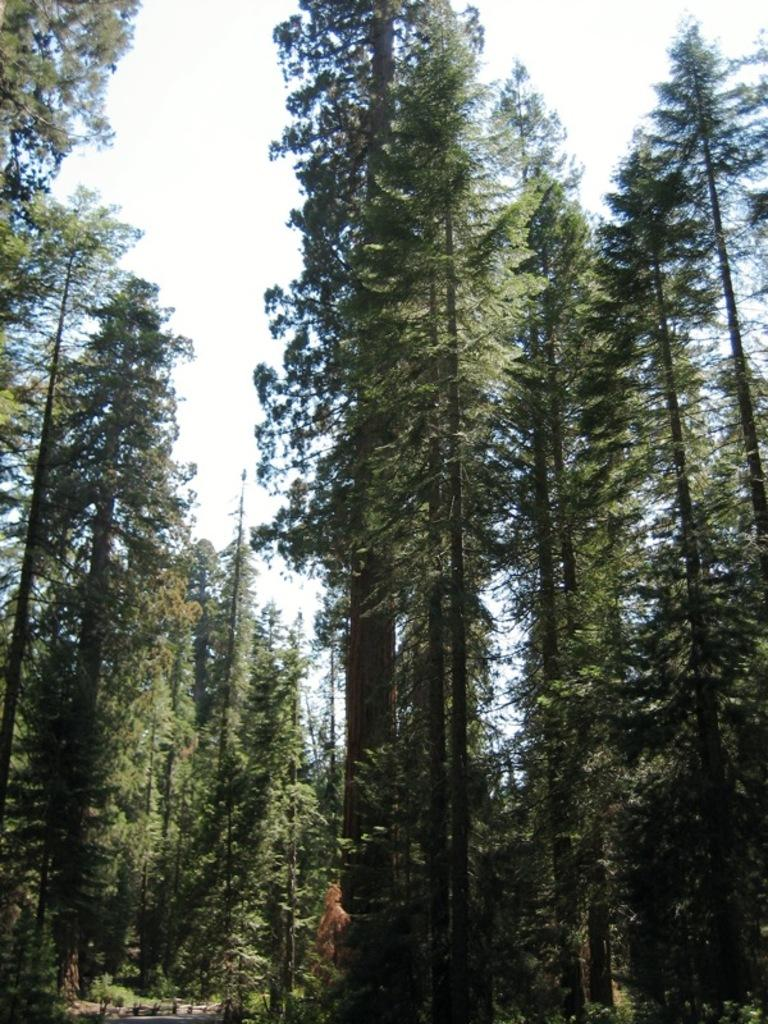What type of vegetation can be seen in the image? There are trees in the image. What part of the natural environment is visible in the image? The sky is visible in the image. What type of doctor can be seen in the image? There is no doctor present in the image; it features trees and sky. What type of food is being prepared in the image? There is no food preparation visible in the image; it only shows trees and sky. 